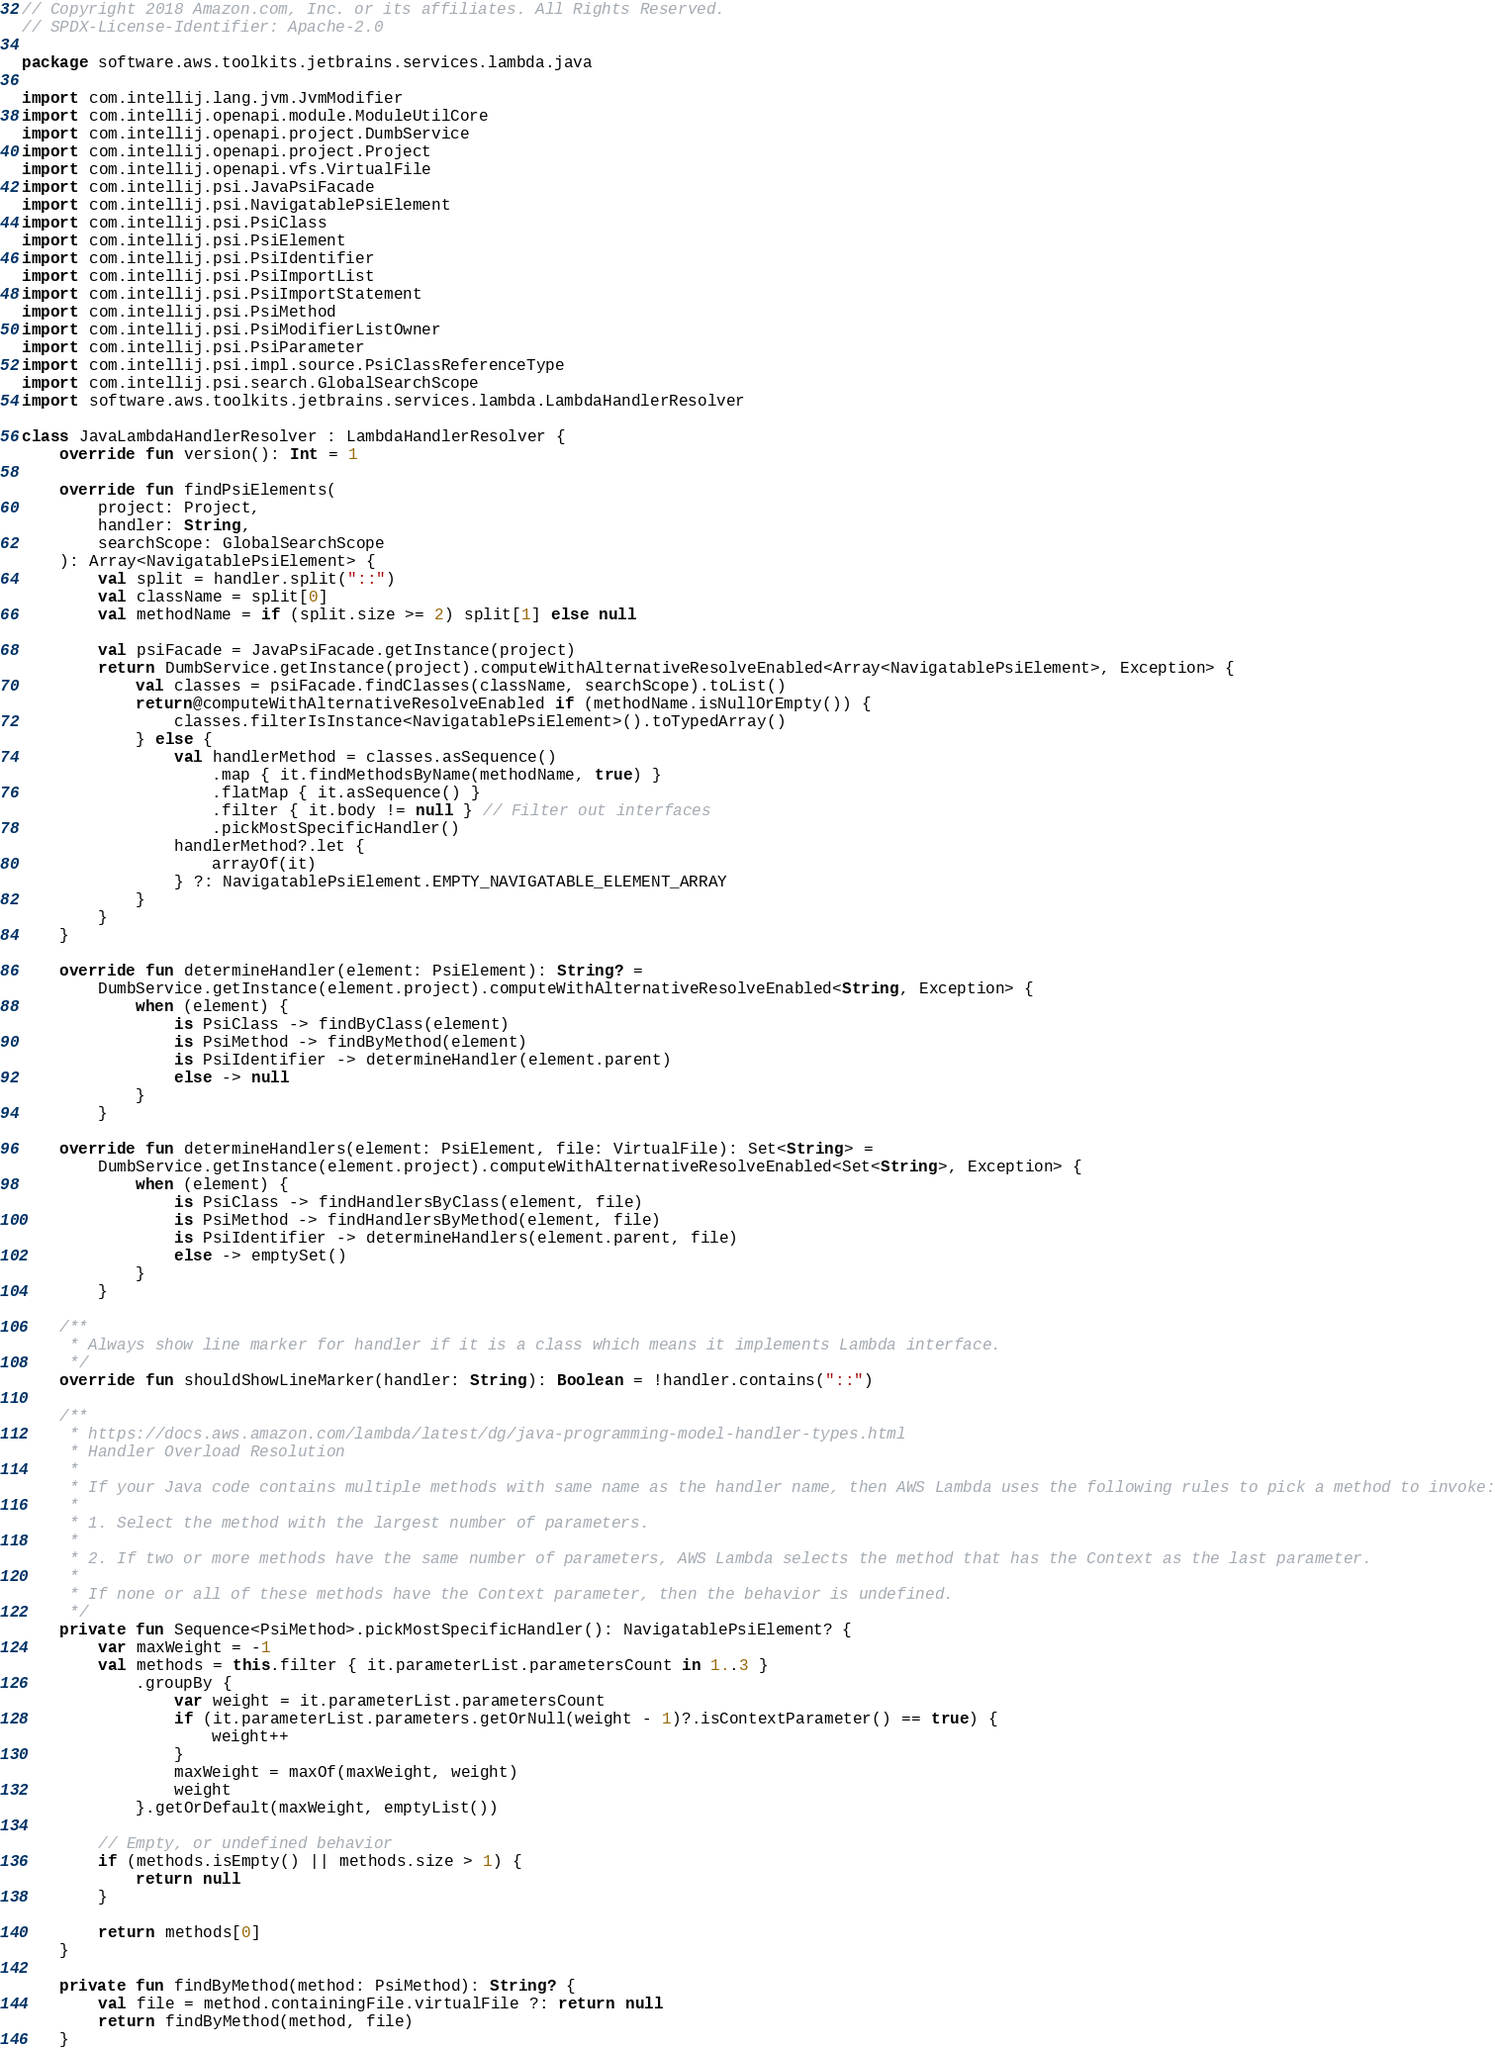<code> <loc_0><loc_0><loc_500><loc_500><_Kotlin_>// Copyright 2018 Amazon.com, Inc. or its affiliates. All Rights Reserved.
// SPDX-License-Identifier: Apache-2.0

package software.aws.toolkits.jetbrains.services.lambda.java

import com.intellij.lang.jvm.JvmModifier
import com.intellij.openapi.module.ModuleUtilCore
import com.intellij.openapi.project.DumbService
import com.intellij.openapi.project.Project
import com.intellij.openapi.vfs.VirtualFile
import com.intellij.psi.JavaPsiFacade
import com.intellij.psi.NavigatablePsiElement
import com.intellij.psi.PsiClass
import com.intellij.psi.PsiElement
import com.intellij.psi.PsiIdentifier
import com.intellij.psi.PsiImportList
import com.intellij.psi.PsiImportStatement
import com.intellij.psi.PsiMethod
import com.intellij.psi.PsiModifierListOwner
import com.intellij.psi.PsiParameter
import com.intellij.psi.impl.source.PsiClassReferenceType
import com.intellij.psi.search.GlobalSearchScope
import software.aws.toolkits.jetbrains.services.lambda.LambdaHandlerResolver

class JavaLambdaHandlerResolver : LambdaHandlerResolver {
    override fun version(): Int = 1

    override fun findPsiElements(
        project: Project,
        handler: String,
        searchScope: GlobalSearchScope
    ): Array<NavigatablePsiElement> {
        val split = handler.split("::")
        val className = split[0]
        val methodName = if (split.size >= 2) split[1] else null

        val psiFacade = JavaPsiFacade.getInstance(project)
        return DumbService.getInstance(project).computeWithAlternativeResolveEnabled<Array<NavigatablePsiElement>, Exception> {
            val classes = psiFacade.findClasses(className, searchScope).toList()
            return@computeWithAlternativeResolveEnabled if (methodName.isNullOrEmpty()) {
                classes.filterIsInstance<NavigatablePsiElement>().toTypedArray()
            } else {
                val handlerMethod = classes.asSequence()
                    .map { it.findMethodsByName(methodName, true) }
                    .flatMap { it.asSequence() }
                    .filter { it.body != null } // Filter out interfaces
                    .pickMostSpecificHandler()
                handlerMethod?.let {
                    arrayOf(it)
                } ?: NavigatablePsiElement.EMPTY_NAVIGATABLE_ELEMENT_ARRAY
            }
        }
    }

    override fun determineHandler(element: PsiElement): String? =
        DumbService.getInstance(element.project).computeWithAlternativeResolveEnabled<String, Exception> {
            when (element) {
                is PsiClass -> findByClass(element)
                is PsiMethod -> findByMethod(element)
                is PsiIdentifier -> determineHandler(element.parent)
                else -> null
            }
        }

    override fun determineHandlers(element: PsiElement, file: VirtualFile): Set<String> =
        DumbService.getInstance(element.project).computeWithAlternativeResolveEnabled<Set<String>, Exception> {
            when (element) {
                is PsiClass -> findHandlersByClass(element, file)
                is PsiMethod -> findHandlersByMethod(element, file)
                is PsiIdentifier -> determineHandlers(element.parent, file)
                else -> emptySet()
            }
        }

    /**
     * Always show line marker for handler if it is a class which means it implements Lambda interface.
     */
    override fun shouldShowLineMarker(handler: String): Boolean = !handler.contains("::")

    /**
     * https://docs.aws.amazon.com/lambda/latest/dg/java-programming-model-handler-types.html
     * Handler Overload Resolution
     *
     * If your Java code contains multiple methods with same name as the handler name, then AWS Lambda uses the following rules to pick a method to invoke:
     *
     * 1. Select the method with the largest number of parameters.
     *
     * 2. If two or more methods have the same number of parameters, AWS Lambda selects the method that has the Context as the last parameter.
     *
     * If none or all of these methods have the Context parameter, then the behavior is undefined.
     */
    private fun Sequence<PsiMethod>.pickMostSpecificHandler(): NavigatablePsiElement? {
        var maxWeight = -1
        val methods = this.filter { it.parameterList.parametersCount in 1..3 }
            .groupBy {
                var weight = it.parameterList.parametersCount
                if (it.parameterList.parameters.getOrNull(weight - 1)?.isContextParameter() == true) {
                    weight++
                }
                maxWeight = maxOf(maxWeight, weight)
                weight
            }.getOrDefault(maxWeight, emptyList())

        // Empty, or undefined behavior
        if (methods.isEmpty() || methods.size > 1) {
            return null
        }

        return methods[0]
    }

    private fun findByMethod(method: PsiMethod): String? {
        val file = method.containingFile.virtualFile ?: return null
        return findByMethod(method, file)
    }
</code> 